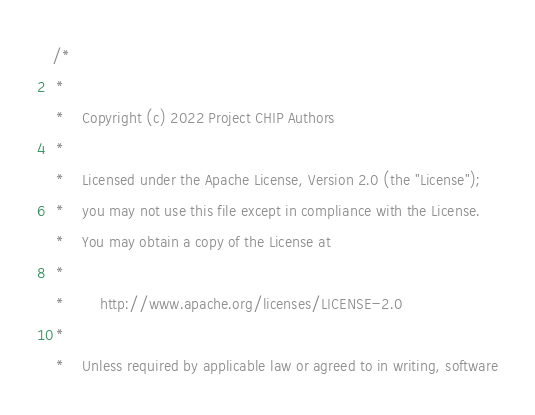Convert code to text. <code><loc_0><loc_0><loc_500><loc_500><_C_>/*
 *
 *    Copyright (c) 2022 Project CHIP Authors
 *
 *    Licensed under the Apache License, Version 2.0 (the "License");
 *    you may not use this file except in compliance with the License.
 *    You may obtain a copy of the License at
 *
 *        http://www.apache.org/licenses/LICENSE-2.0
 *
 *    Unless required by applicable law or agreed to in writing, software</code> 